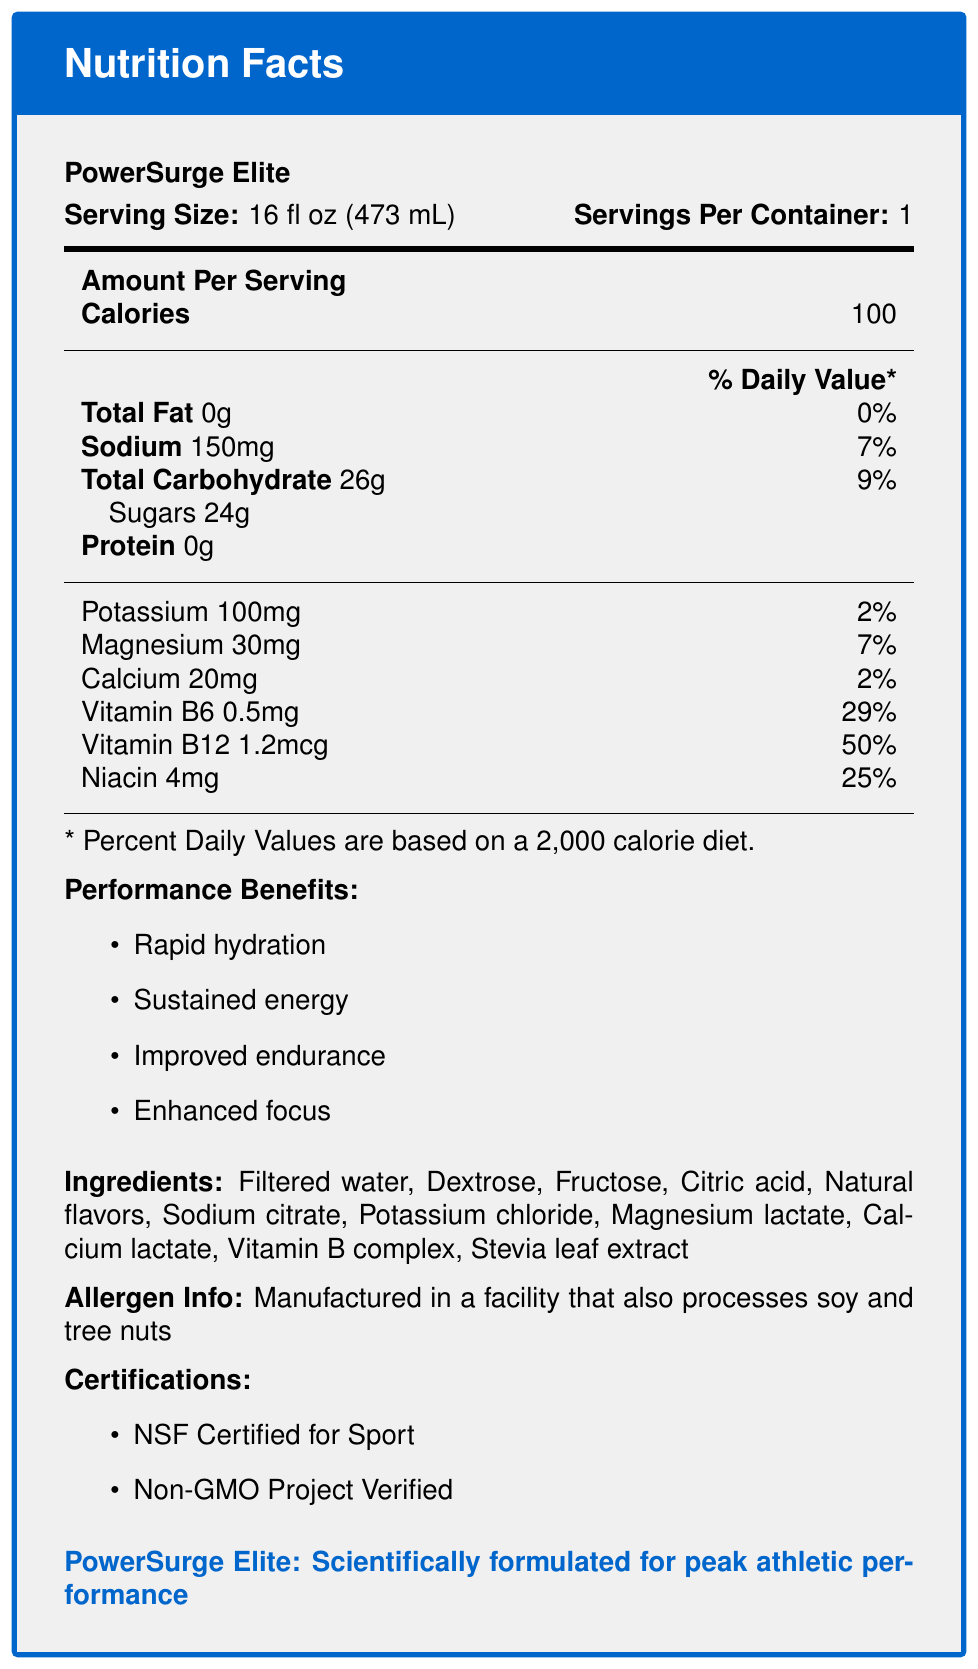what is the serving size of PowerSurge Elite? The serving size is explicitly stated on the nutrition facts label.
Answer: 16 fl oz (473 mL) how many calories are in one serving of PowerSurge Elite? The number of calories per serving is given in the "Amount Per Serving" section.
Answer: 100 what is the percentage of daily value for Sodium? The percentage of daily value for Sodium is listed in the nutritional information on the label.
Answer: 7% which certifications does PowerSurge Elite have? The certifications are listed under the "Certifications" section in the document.
Answer: NSF Certified for Sport, Non-GMO Project Verified what are the main ingredients of PowerSurge Elite? The ingredients are explicitly listed under the "Ingredients" section.
Answer: Filtered water, Dextrose, Fructose, Citric acid, Natural flavors, Sodium citrate, Potassium chloride, Magnesium lactate, Calcium lactate, Vitamin B complex, Stevia leaf extract what flavor is PowerSurge Elite? The flavor profile is mentioned in the data provided and is noted as "Citrus Burst".
Answer: Citrus Burst what is the recommended use for PowerSurge Elite? A. After meals B. Before sleep C. Before, during, or after intense physical activity D. As a substitute for water The recommended use is specified as "Consume before, during, or after intense physical activity".
Answer: C how much Potassium is in one serving of PowerSurge Elite? A. 50mg B. 100mg C. 150mg D. 200mg The amount of Potassium per serving is listed as 100mg in the nutritional information.
Answer: B does PowerSurge Elite contain any artificial colors or preservatives? According to the marketing claims, PowerSurge Elite has "No artificial colors or preservatives".
Answer: No is the bottle of PowerSurge Elite recyclable? The packaging recyclability is listed as "100% recyclable bottle" in the document.
Answer: Yes what is the total carbohydrate content per serving of PowerSurge Elite? The total carbohydrate content is listed as 26g per serving.
Answer: 26g describe the performance benefits of PowerSurge Elite. The document lists these performance benefits explicitly under the "Performance Benefits" section.
Answer: The performance benefits of PowerSurge Elite include rapid hydration, sustained energy, improved endurance, and enhanced focus how does PowerSurge Elite compare to competitors in terms of electrolyte content? The competitor comparison section indicates that the electrolyte content is 20% higher than leading competitors.
Answer: 20% higher what certifications relate to athlete health and safety and non-genetically modified organisms? These certifications are specifically mentioned under the "Certifications" section and relate to athletes' health and non-GMO food products.
Answer: NSF Certified for Sport, Non-GMO Project Verified is PowerSurge Elite suitable for vegans? The document does not provide any information about whether PowerSurge Elite is suitable for vegans.
Answer: Cannot be determined 